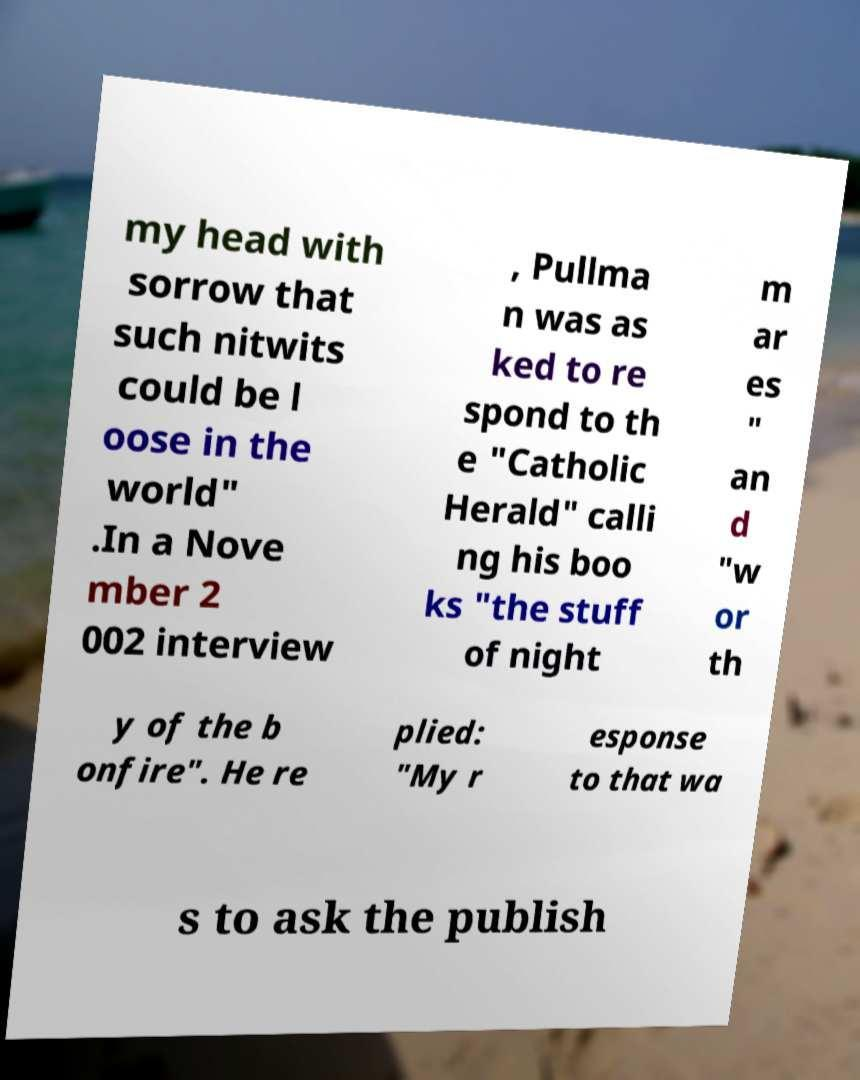What messages or text are displayed in this image? I need them in a readable, typed format. my head with sorrow that such nitwits could be l oose in the world" .In a Nove mber 2 002 interview , Pullma n was as ked to re spond to th e "Catholic Herald" calli ng his boo ks "the stuff of night m ar es " an d "w or th y of the b onfire". He re plied: "My r esponse to that wa s to ask the publish 